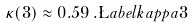Convert formula to latex. <formula><loc_0><loc_0><loc_500><loc_500>\kappa ( 3 ) \approx 0 . 5 9 \, . \L a b e l { k a p p a 3 }</formula> 